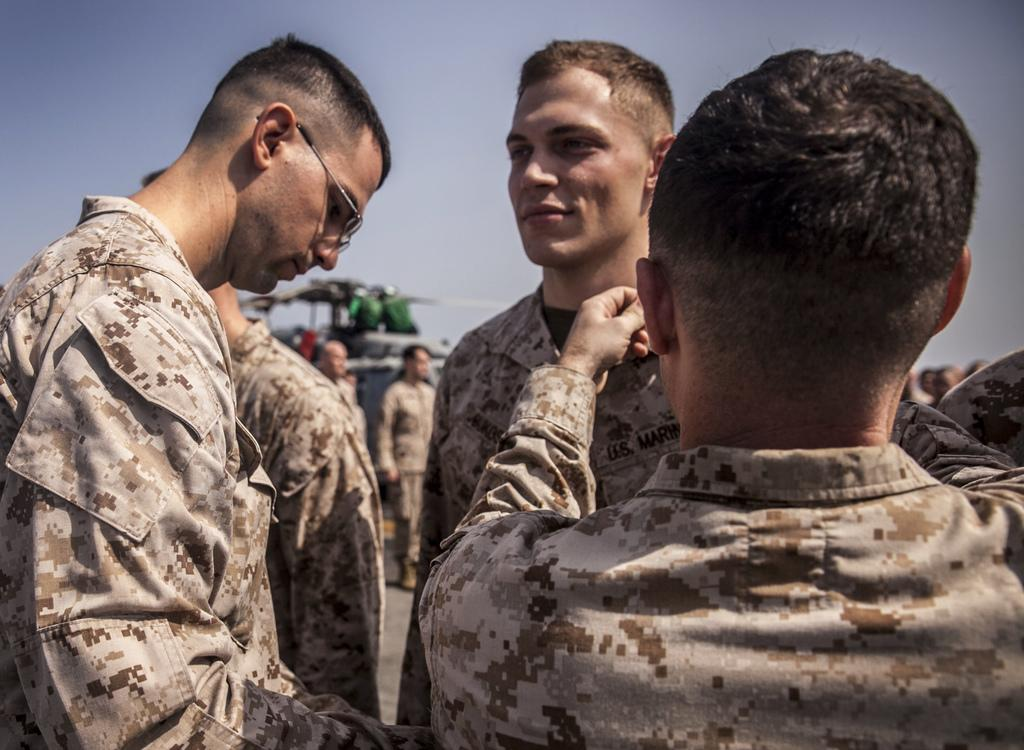What type of people are in the image? There are men in the image. What are the men wearing? The men are wearing brown-colored dresses. Can you describe the man on the left side of the image? There is a man wearing spectacles on the left side of the image. What can be seen in the background of the image? There is a chopper and the sky visible in the background of the image. How many hens are visible in the image? There are no hens present in the image. What type of pest can be seen in the image? There is no pest visible in the image. 